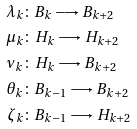Convert formula to latex. <formula><loc_0><loc_0><loc_500><loc_500>\lambda _ { k } & \colon B _ { k } \longrightarrow B _ { k + 2 } \\ \mu _ { k } & \colon H _ { k } \longrightarrow H _ { k + 2 } \\ \nu _ { k } & \colon H _ { k } \longrightarrow B _ { k + 2 } \\ \theta _ { k } & \colon B _ { k - 1 } \longrightarrow B _ { k + 2 } \\ \zeta _ { k } & \colon B _ { k - 1 } \longrightarrow H _ { k + 2 }</formula> 